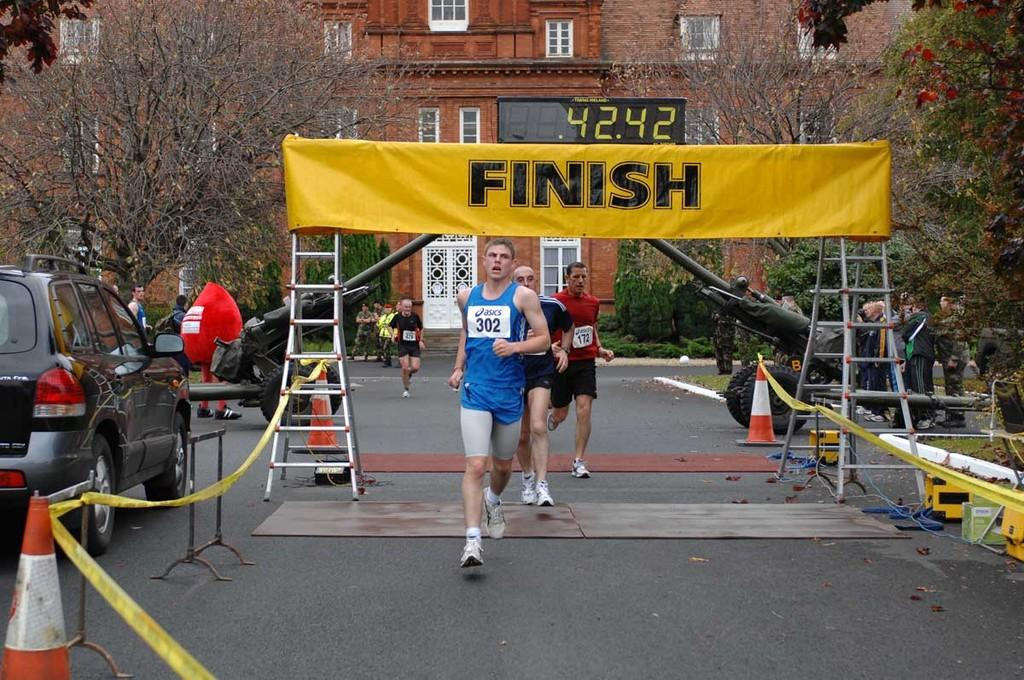<image>
Offer a succinct explanation of the picture presented. Three runners are crossing the yellow finish line. 